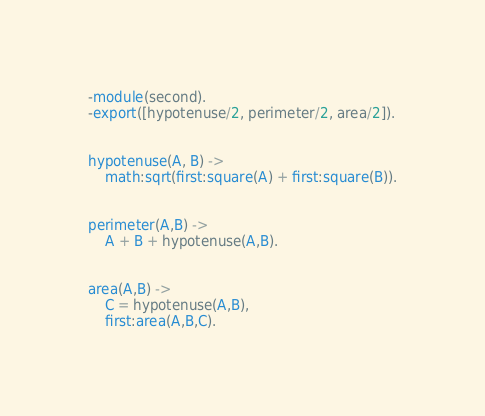<code> <loc_0><loc_0><loc_500><loc_500><_Erlang_>-module(second).
-export([hypotenuse/2, perimeter/2, area/2]).


hypotenuse(A, B) ->
    math:sqrt(first:square(A) + first:square(B)).


perimeter(A,B) ->
    A + B + hypotenuse(A,B).


area(A,B) ->
    C = hypotenuse(A,B),
    first:area(A,B,C).
</code> 